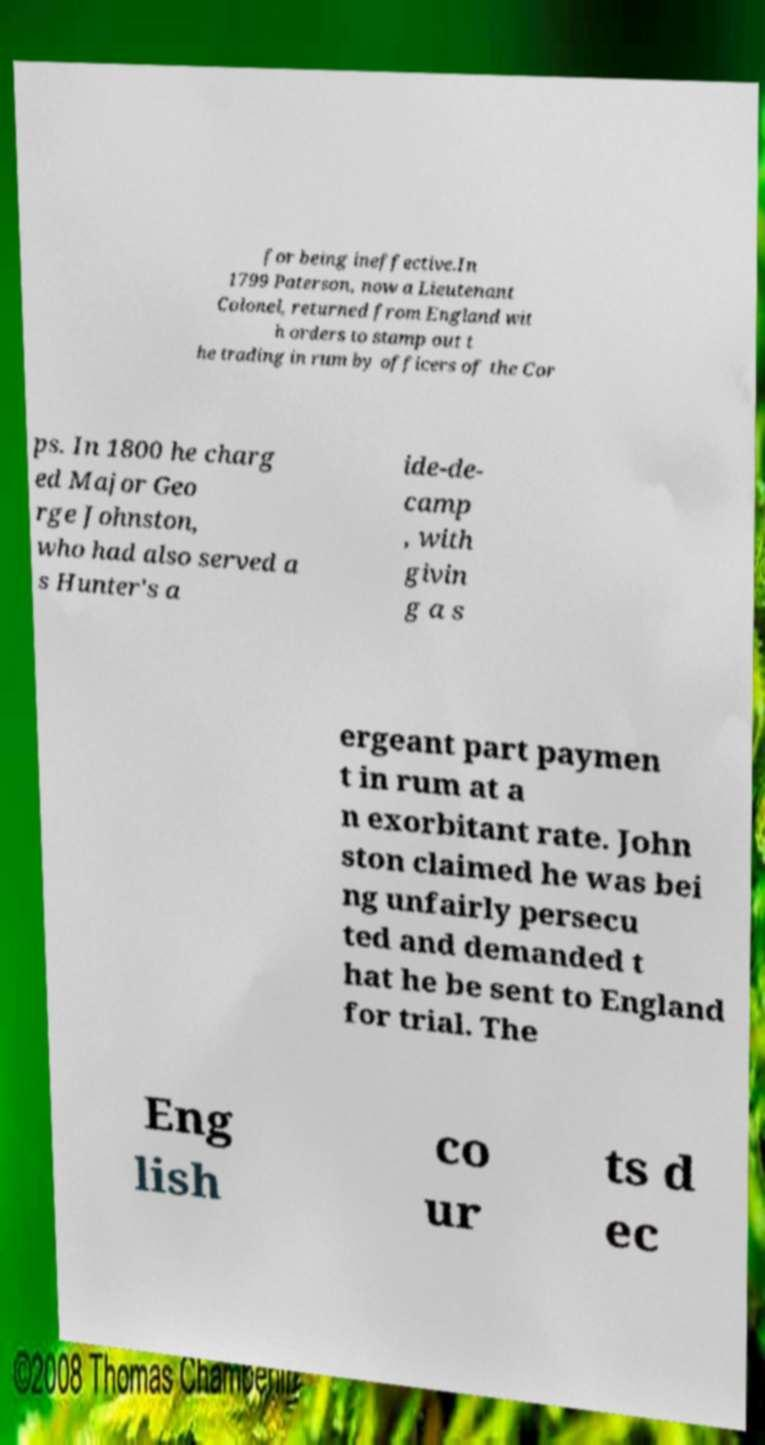There's text embedded in this image that I need extracted. Can you transcribe it verbatim? for being ineffective.In 1799 Paterson, now a Lieutenant Colonel, returned from England wit h orders to stamp out t he trading in rum by officers of the Cor ps. In 1800 he charg ed Major Geo rge Johnston, who had also served a s Hunter's a ide-de- camp , with givin g a s ergeant part paymen t in rum at a n exorbitant rate. John ston claimed he was bei ng unfairly persecu ted and demanded t hat he be sent to England for trial. The Eng lish co ur ts d ec 